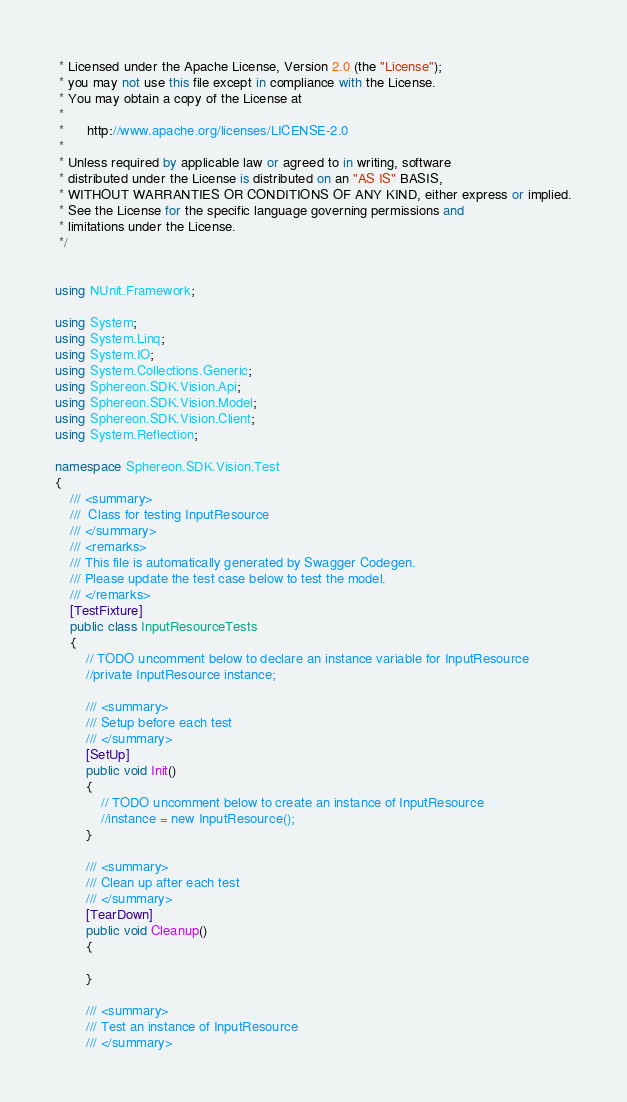<code> <loc_0><loc_0><loc_500><loc_500><_C#_> * Licensed under the Apache License, Version 2.0 (the "License");
 * you may not use this file except in compliance with the License.
 * You may obtain a copy of the License at
 *
 *      http://www.apache.org/licenses/LICENSE-2.0
 *
 * Unless required by applicable law or agreed to in writing, software
 * distributed under the License is distributed on an "AS IS" BASIS,
 * WITHOUT WARRANTIES OR CONDITIONS OF ANY KIND, either express or implied.
 * See the License for the specific language governing permissions and
 * limitations under the License.
 */


using NUnit.Framework;

using System;
using System.Linq;
using System.IO;
using System.Collections.Generic;
using Sphereon.SDK.Vision.Api;
using Sphereon.SDK.Vision.Model;
using Sphereon.SDK.Vision.Client;
using System.Reflection;

namespace Sphereon.SDK.Vision.Test
{
    /// <summary>
    ///  Class for testing InputResource
    /// </summary>
    /// <remarks>
    /// This file is automatically generated by Swagger Codegen.
    /// Please update the test case below to test the model.
    /// </remarks>
    [TestFixture]
    public class InputResourceTests
    {
        // TODO uncomment below to declare an instance variable for InputResource
        //private InputResource instance;

        /// <summary>
        /// Setup before each test
        /// </summary>
        [SetUp]
        public void Init()
        {
            // TODO uncomment below to create an instance of InputResource
            //instance = new InputResource();
        }

        /// <summary>
        /// Clean up after each test
        /// </summary>
        [TearDown]
        public void Cleanup()
        {

        }

        /// <summary>
        /// Test an instance of InputResource
        /// </summary></code> 